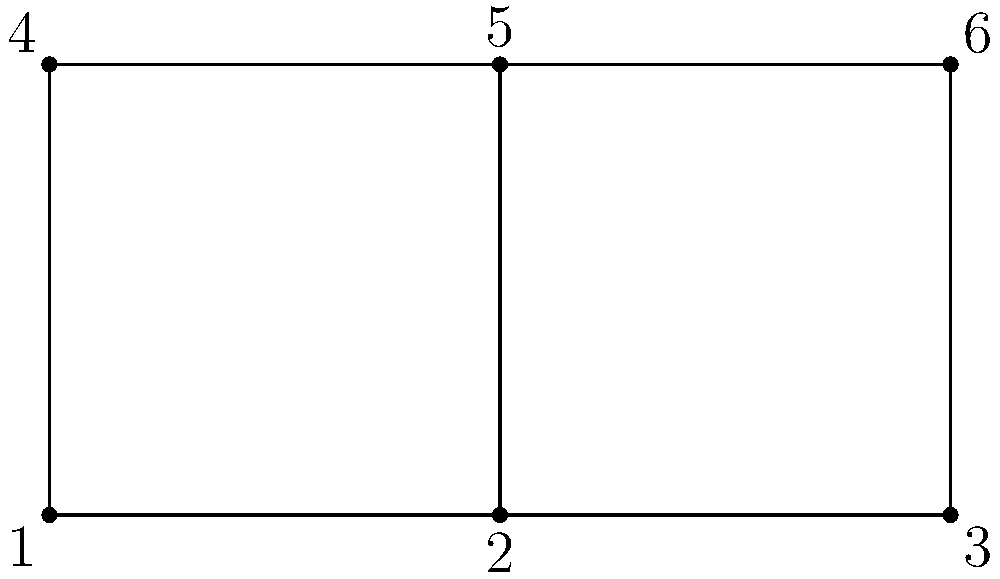In a typical news broadcast setup, there are six camera positions arranged in a 2x3 grid as shown in the diagram. How many unique ways can you arrange a sequence of shots using all six cameras exactly once, if the broadcast must start with either camera 1 or camera 4 (top-left or bottom-left) due to the anchor's position? Let's approach this step-by-step:

1) First, we need to understand that this is a permutation problem, but with a constraint on the first element.

2) The total number of cameras is 6, so without any constraints, we would have 6! (6 factorial) permutations.

3) However, we are given a constraint: the sequence must start with either camera 1 or camera 4.

4) This means we can break our problem into two parts:
   a) Sequences starting with camera 1
   b) Sequences starting with camera 4

5) For sequences starting with camera 1:
   - We have 1 fixed camera (camera 1)
   - We need to arrange the remaining 5 cameras
   - This gives us 5! permutations

6) The same logic applies for sequences starting with camera 4:
   - We have 1 fixed camera (camera 4)
   - We need to arrange the remaining 5 cameras
   - This also gives us 5! permutations

7) Since we can start with either camera 1 or camera 4, we need to add these two sets of permutations together.

8) Therefore, the total number of unique arrangements is:
   $5! + 5! = 2 * 5! = 2 * 120 = 240$

Thus, there are 240 unique ways to arrange the sequence of shots under the given constraints.
Answer: 240 